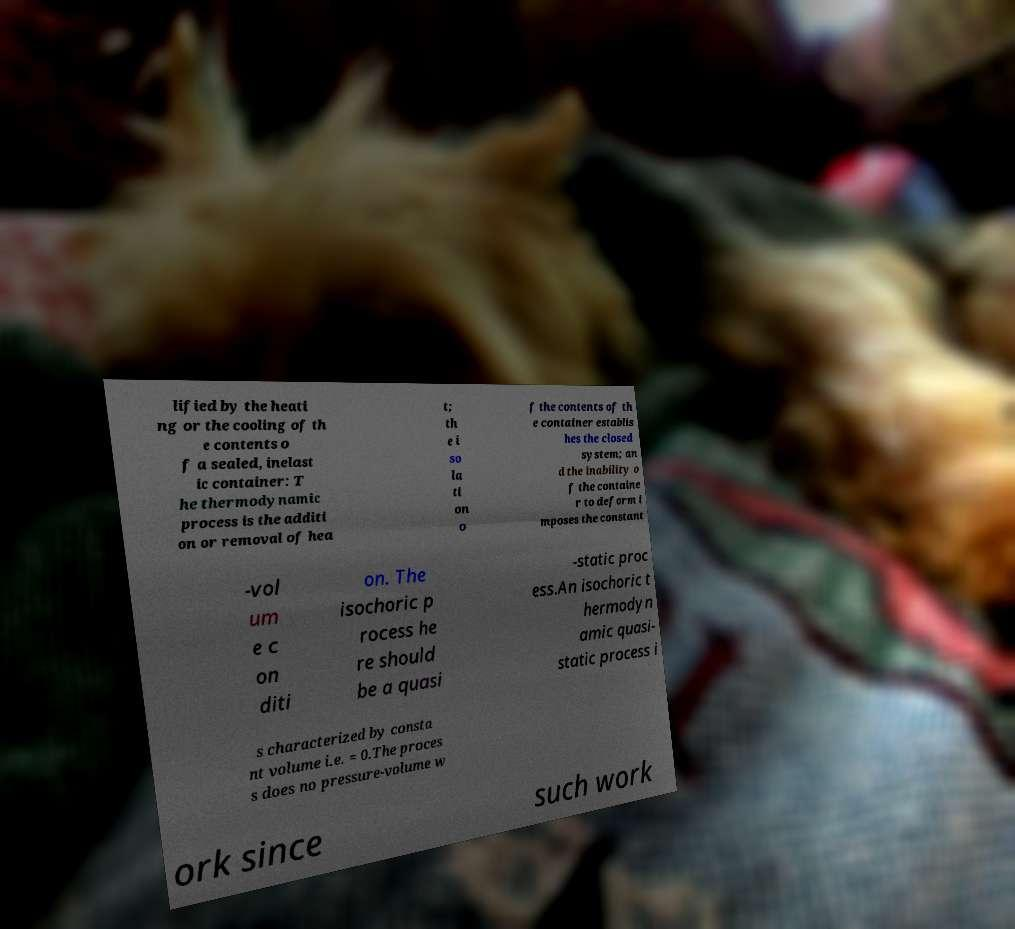Can you read and provide the text displayed in the image?This photo seems to have some interesting text. Can you extract and type it out for me? lified by the heati ng or the cooling of th e contents o f a sealed, inelast ic container: T he thermodynamic process is the additi on or removal of hea t; th e i so la ti on o f the contents of th e container establis hes the closed system; an d the inability o f the containe r to deform i mposes the constant -vol um e c on diti on. The isochoric p rocess he re should be a quasi -static proc ess.An isochoric t hermodyn amic quasi- static process i s characterized by consta nt volume i.e. = 0.The proces s does no pressure-volume w ork since such work 